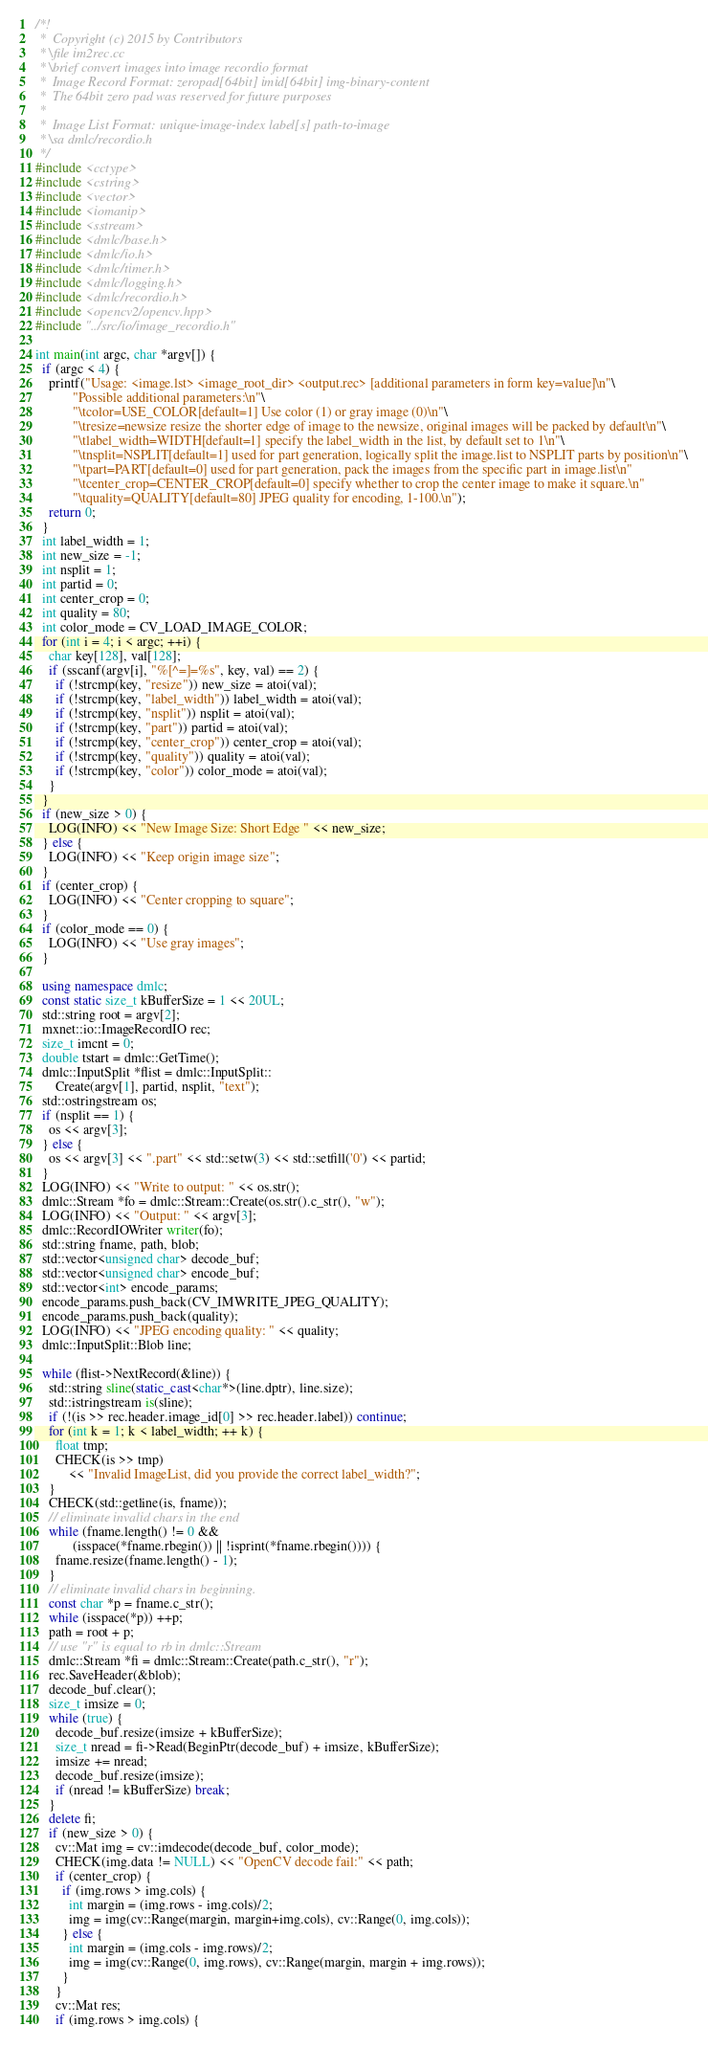<code> <loc_0><loc_0><loc_500><loc_500><_C++_>/*!
 *  Copyright (c) 2015 by Contributors
 * \file im2rec.cc
 * \brief convert images into image recordio format
 *  Image Record Format: zeropad[64bit] imid[64bit] img-binary-content
 *  The 64bit zero pad was reserved for future purposes
 *
 *  Image List Format: unique-image-index label[s] path-to-image
 * \sa dmlc/recordio.h
 */
#include <cctype>
#include <cstring>
#include <vector>
#include <iomanip>
#include <sstream>
#include <dmlc/base.h>
#include <dmlc/io.h>
#include <dmlc/timer.h>
#include <dmlc/logging.h>
#include <dmlc/recordio.h>
#include <opencv2/opencv.hpp>
#include "../src/io/image_recordio.h"

int main(int argc, char *argv[]) {
  if (argc < 4) {
    printf("Usage: <image.lst> <image_root_dir> <output.rec> [additional parameters in form key=value]\n"\
           "Possible additional parameters:\n"\
           "\tcolor=USE_COLOR[default=1] Use color (1) or gray image (0)\n"\
           "\tresize=newsize resize the shorter edge of image to the newsize, original images will be packed by default\n"\
           "\tlabel_width=WIDTH[default=1] specify the label_width in the list, by default set to 1\n"\
           "\tnsplit=NSPLIT[default=1] used for part generation, logically split the image.list to NSPLIT parts by position\n"\
           "\tpart=PART[default=0] used for part generation, pack the images from the specific part in image.list\n"
           "\tcenter_crop=CENTER_CROP[default=0] specify whether to crop the center image to make it square.\n"
           "\tquality=QUALITY[default=80] JPEG quality for encoding, 1-100.\n");
    return 0;
  }
  int label_width = 1;
  int new_size = -1;
  int nsplit = 1;
  int partid = 0;
  int center_crop = 0;
  int quality = 80;
  int color_mode = CV_LOAD_IMAGE_COLOR;
  for (int i = 4; i < argc; ++i) {
    char key[128], val[128];
    if (sscanf(argv[i], "%[^=]=%s", key, val) == 2) {
      if (!strcmp(key, "resize")) new_size = atoi(val);
      if (!strcmp(key, "label_width")) label_width = atoi(val);
      if (!strcmp(key, "nsplit")) nsplit = atoi(val);
      if (!strcmp(key, "part")) partid = atoi(val);
      if (!strcmp(key, "center_crop")) center_crop = atoi(val);
      if (!strcmp(key, "quality")) quality = atoi(val);
      if (!strcmp(key, "color")) color_mode = atoi(val);
    }
  }
  if (new_size > 0) {
    LOG(INFO) << "New Image Size: Short Edge " << new_size;
  } else {
    LOG(INFO) << "Keep origin image size";
  }
  if (center_crop) {
    LOG(INFO) << "Center cropping to square";
  }
  if (color_mode == 0) {
    LOG(INFO) << "Use gray images";
  }
  
  using namespace dmlc;
  const static size_t kBufferSize = 1 << 20UL;
  std::string root = argv[2];
  mxnet::io::ImageRecordIO rec;
  size_t imcnt = 0;
  double tstart = dmlc::GetTime();
  dmlc::InputSplit *flist = dmlc::InputSplit::
      Create(argv[1], partid, nsplit, "text");  
  std::ostringstream os;
  if (nsplit == 1) {
    os << argv[3];
  } else {
    os << argv[3] << ".part" << std::setw(3) << std::setfill('0') << partid;
  }
  LOG(INFO) << "Write to output: " << os.str();
  dmlc::Stream *fo = dmlc::Stream::Create(os.str().c_str(), "w");
  LOG(INFO) << "Output: " << argv[3];
  dmlc::RecordIOWriter writer(fo);
  std::string fname, path, blob;
  std::vector<unsigned char> decode_buf;
  std::vector<unsigned char> encode_buf;
  std::vector<int> encode_params;
  encode_params.push_back(CV_IMWRITE_JPEG_QUALITY);
  encode_params.push_back(quality);
  LOG(INFO) << "JPEG encoding quality: " << quality;
  dmlc::InputSplit::Blob line;

  while (flist->NextRecord(&line)) {
    std::string sline(static_cast<char*>(line.dptr), line.size);
    std::istringstream is(sline);
    if (!(is >> rec.header.image_id[0] >> rec.header.label)) continue;
    for (int k = 1; k < label_width; ++ k) {
      float tmp;
      CHECK(is >> tmp)
          << "Invalid ImageList, did you provide the correct label_width?";
    }
    CHECK(std::getline(is, fname));
    // eliminate invalid chars in the end
    while (fname.length() != 0 &&
           (isspace(*fname.rbegin()) || !isprint(*fname.rbegin()))) {
      fname.resize(fname.length() - 1);
    }
    // eliminate invalid chars in beginning.
    const char *p = fname.c_str();
    while (isspace(*p)) ++p;
    path = root + p;
    // use "r" is equal to rb in dmlc::Stream
    dmlc::Stream *fi = dmlc::Stream::Create(path.c_str(), "r");
    rec.SaveHeader(&blob);
    decode_buf.clear();
    size_t imsize = 0;
    while (true) {
      decode_buf.resize(imsize + kBufferSize);
      size_t nread = fi->Read(BeginPtr(decode_buf) + imsize, kBufferSize);
      imsize += nread;
      decode_buf.resize(imsize);
      if (nread != kBufferSize) break;
    }
    delete fi;
    if (new_size > 0) {
      cv::Mat img = cv::imdecode(decode_buf, color_mode);
      CHECK(img.data != NULL) << "OpenCV decode fail:" << path;
      if (center_crop) {
        if (img.rows > img.cols) {
          int margin = (img.rows - img.cols)/2;
          img = img(cv::Range(margin, margin+img.cols), cv::Range(0, img.cols));
        } else {
          int margin = (img.cols - img.rows)/2;
          img = img(cv::Range(0, img.rows), cv::Range(margin, margin + img.rows));
        }
      }
      cv::Mat res;
      if (img.rows > img.cols) {</code> 